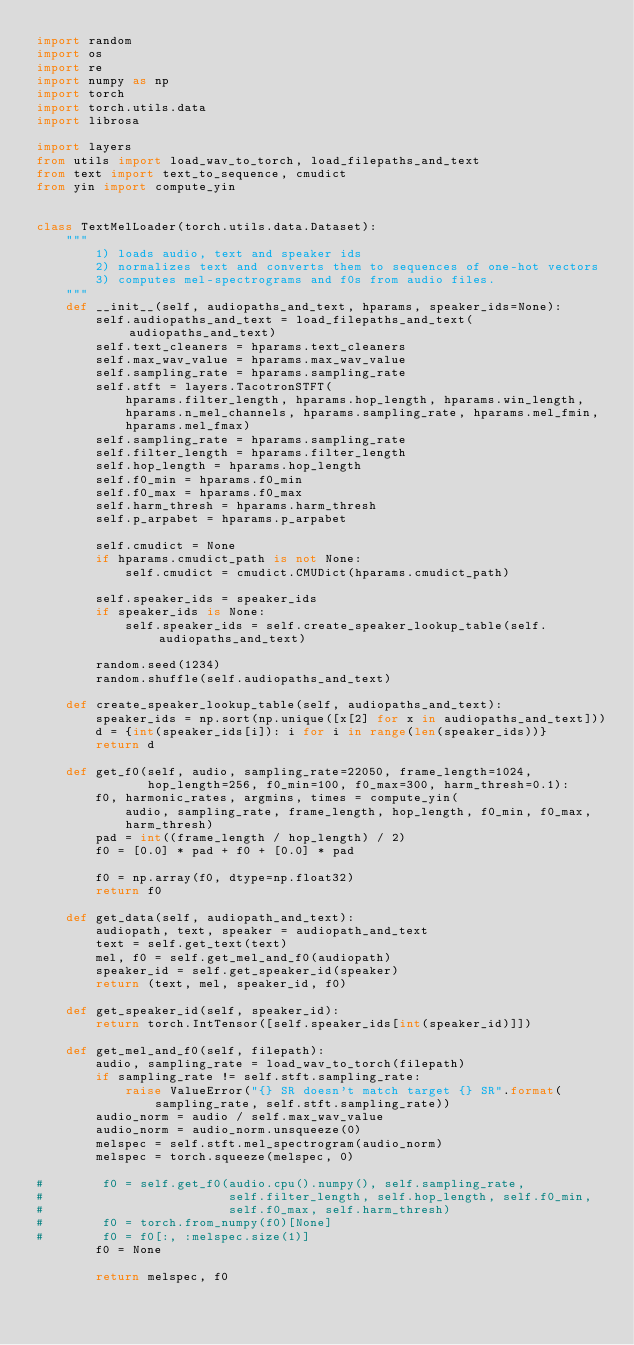<code> <loc_0><loc_0><loc_500><loc_500><_Python_>import random
import os
import re
import numpy as np
import torch
import torch.utils.data
import librosa

import layers
from utils import load_wav_to_torch, load_filepaths_and_text
from text import text_to_sequence, cmudict
from yin import compute_yin


class TextMelLoader(torch.utils.data.Dataset):
    """
        1) loads audio, text and speaker ids
        2) normalizes text and converts them to sequences of one-hot vectors
        3) computes mel-spectrograms and f0s from audio files.
    """
    def __init__(self, audiopaths_and_text, hparams, speaker_ids=None):
        self.audiopaths_and_text = load_filepaths_and_text(audiopaths_and_text)
        self.text_cleaners = hparams.text_cleaners
        self.max_wav_value = hparams.max_wav_value
        self.sampling_rate = hparams.sampling_rate
        self.stft = layers.TacotronSTFT(
            hparams.filter_length, hparams.hop_length, hparams.win_length,
            hparams.n_mel_channels, hparams.sampling_rate, hparams.mel_fmin,
            hparams.mel_fmax)
        self.sampling_rate = hparams.sampling_rate
        self.filter_length = hparams.filter_length
        self.hop_length = hparams.hop_length
        self.f0_min = hparams.f0_min
        self.f0_max = hparams.f0_max
        self.harm_thresh = hparams.harm_thresh
        self.p_arpabet = hparams.p_arpabet

        self.cmudict = None
        if hparams.cmudict_path is not None:
            self.cmudict = cmudict.CMUDict(hparams.cmudict_path)

        self.speaker_ids = speaker_ids
        if speaker_ids is None:
            self.speaker_ids = self.create_speaker_lookup_table(self.audiopaths_and_text)

        random.seed(1234)
        random.shuffle(self.audiopaths_and_text)

    def create_speaker_lookup_table(self, audiopaths_and_text):
        speaker_ids = np.sort(np.unique([x[2] for x in audiopaths_and_text]))
        d = {int(speaker_ids[i]): i for i in range(len(speaker_ids))}
        return d

    def get_f0(self, audio, sampling_rate=22050, frame_length=1024,
               hop_length=256, f0_min=100, f0_max=300, harm_thresh=0.1):
        f0, harmonic_rates, argmins, times = compute_yin(
            audio, sampling_rate, frame_length, hop_length, f0_min, f0_max,
            harm_thresh)
        pad = int((frame_length / hop_length) / 2)
        f0 = [0.0] * pad + f0 + [0.0] * pad

        f0 = np.array(f0, dtype=np.float32)
        return f0

    def get_data(self, audiopath_and_text):
        audiopath, text, speaker = audiopath_and_text
        text = self.get_text(text)
        mel, f0 = self.get_mel_and_f0(audiopath)
        speaker_id = self.get_speaker_id(speaker)
        return (text, mel, speaker_id, f0)

    def get_speaker_id(self, speaker_id):
        return torch.IntTensor([self.speaker_ids[int(speaker_id)]])

    def get_mel_and_f0(self, filepath):
        audio, sampling_rate = load_wav_to_torch(filepath)
        if sampling_rate != self.stft.sampling_rate:
            raise ValueError("{} SR doesn't match target {} SR".format(
                sampling_rate, self.stft.sampling_rate))
        audio_norm = audio / self.max_wav_value
        audio_norm = audio_norm.unsqueeze(0)
        melspec = self.stft.mel_spectrogram(audio_norm)
        melspec = torch.squeeze(melspec, 0)

#        f0 = self.get_f0(audio.cpu().numpy(), self.sampling_rate,
#                         self.filter_length, self.hop_length, self.f0_min,
#                         self.f0_max, self.harm_thresh)
#        f0 = torch.from_numpy(f0)[None]
#        f0 = f0[:, :melspec.size(1)]
        f0 = None

        return melspec, f0
</code> 